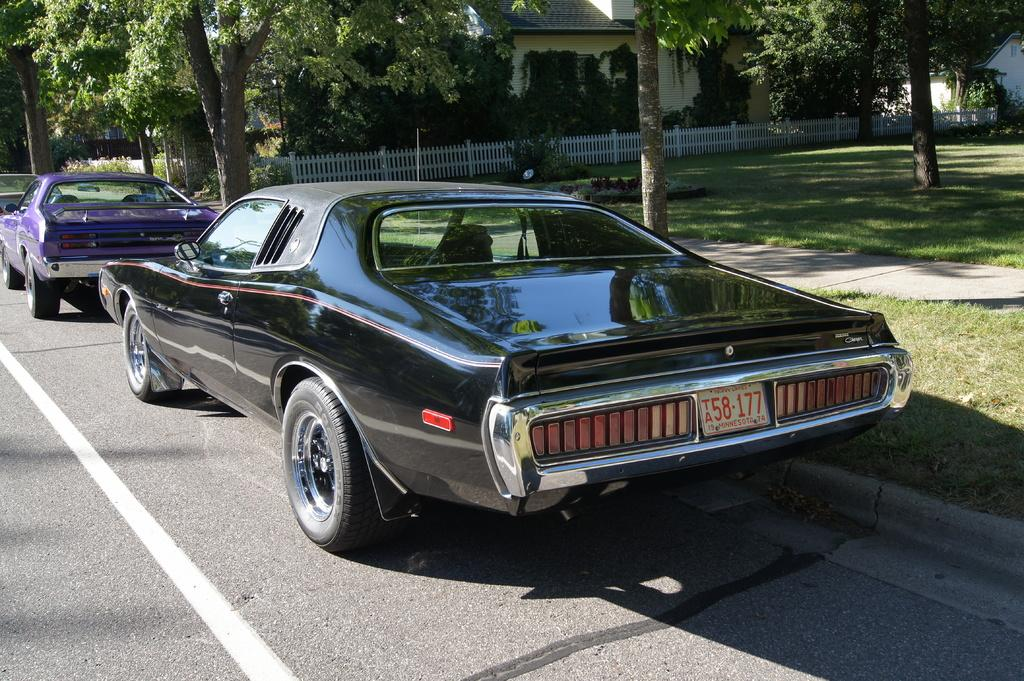How many vehicles can be seen on the road in the image? There are two vehicles on the road in the image. What type of natural elements are visible in the image? There are many trees visible in the image. What feature is present to provide safety or support? There is a railing present in the image. What type of structures can be seen in the background? There are houses visible in the image. How many twigs can be seen on the road in the image? There are no twigs visible on the road in the image. What type of currency is present in the image? There is no currency visible in the image. 